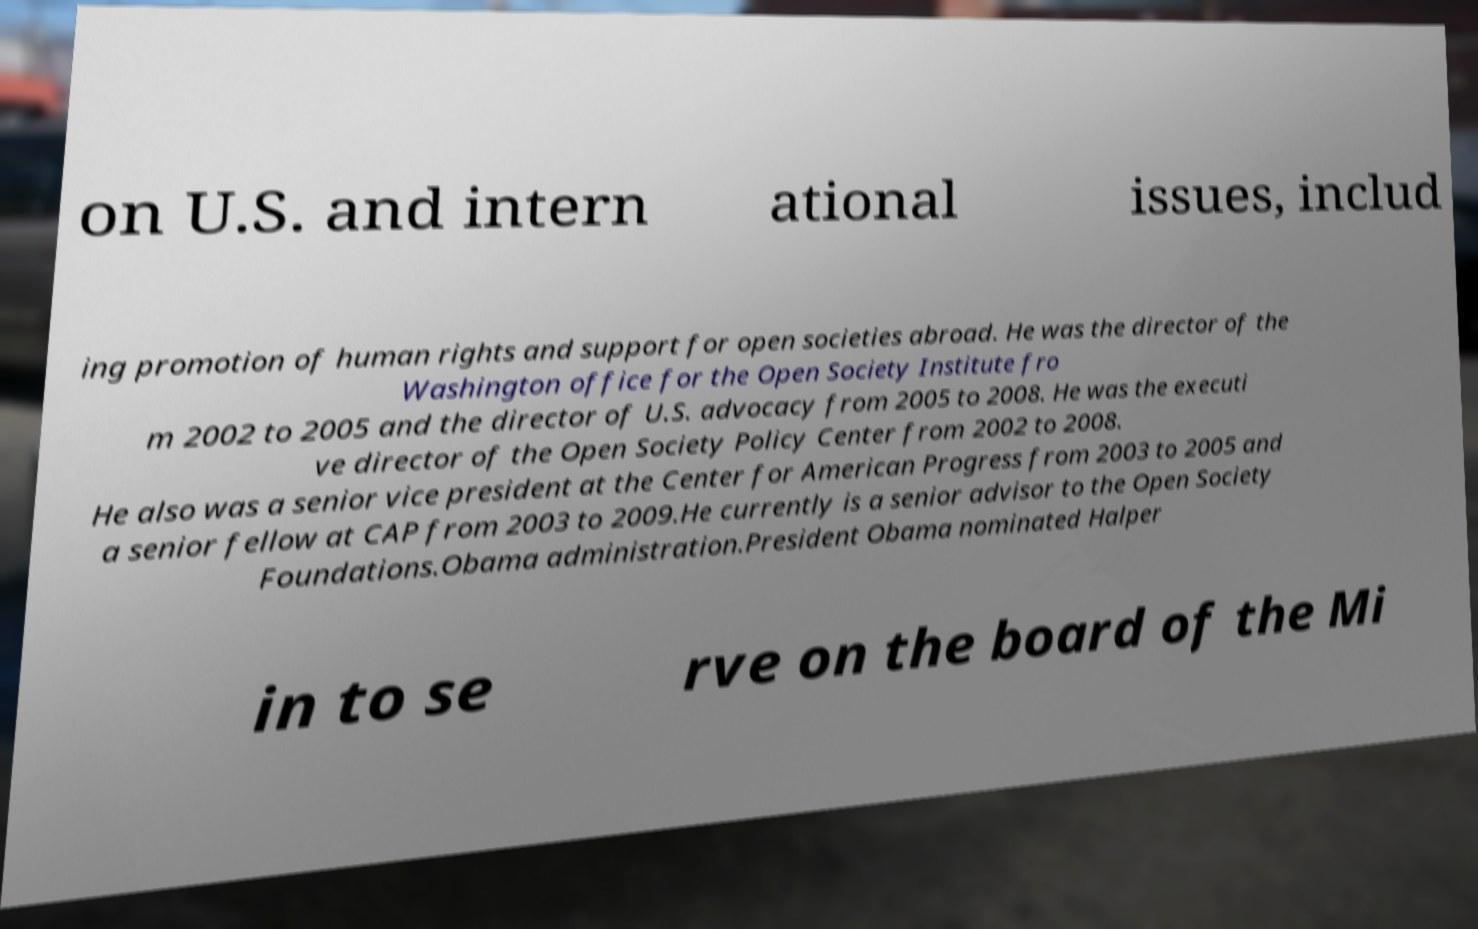There's text embedded in this image that I need extracted. Can you transcribe it verbatim? on U.S. and intern ational issues, includ ing promotion of human rights and support for open societies abroad. He was the director of the Washington office for the Open Society Institute fro m 2002 to 2005 and the director of U.S. advocacy from 2005 to 2008. He was the executi ve director of the Open Society Policy Center from 2002 to 2008. He also was a senior vice president at the Center for American Progress from 2003 to 2005 and a senior fellow at CAP from 2003 to 2009.He currently is a senior advisor to the Open Society Foundations.Obama administration.President Obama nominated Halper in to se rve on the board of the Mi 